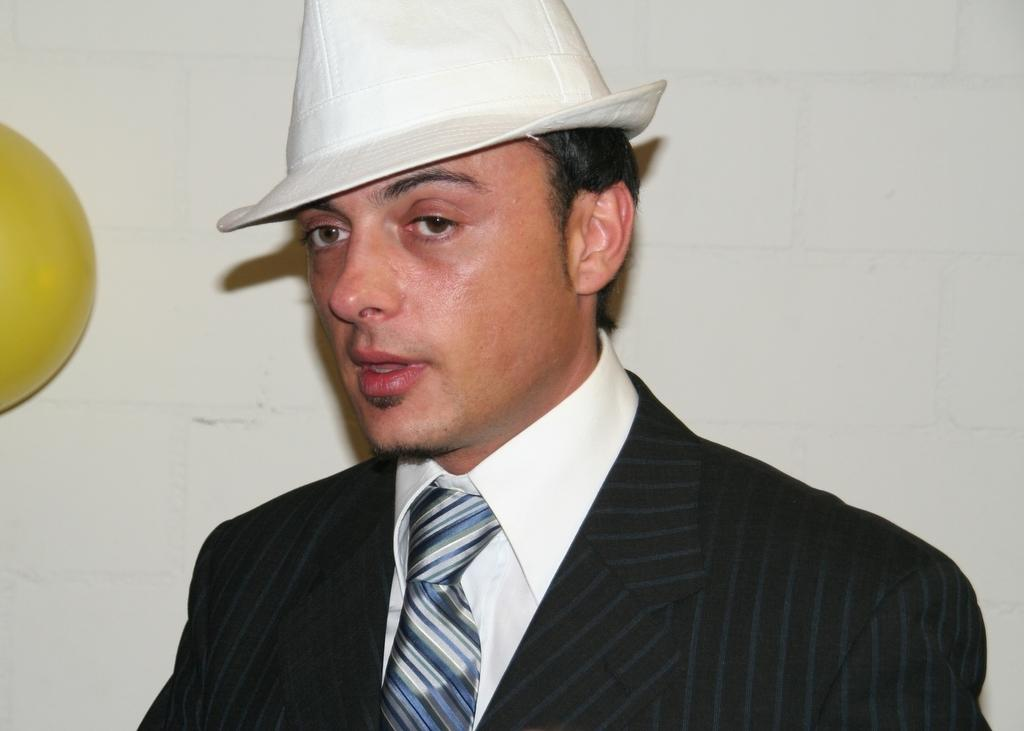Who is present in the image? There is a man in the image. What is the man wearing on his head? The man is wearing a cap. What type of clothing is the man wearing? The man is wearing a suit. What can be seen on the left side of the image? There is a yellow ball on the left side of the image. What is visible in the background of the image? There is a wall visible in the background of the image. What type of toothbrush is the man using in the image? There is no toothbrush present in the image. What tax-related information can be found in the image? There is no tax-related information present in the image. 